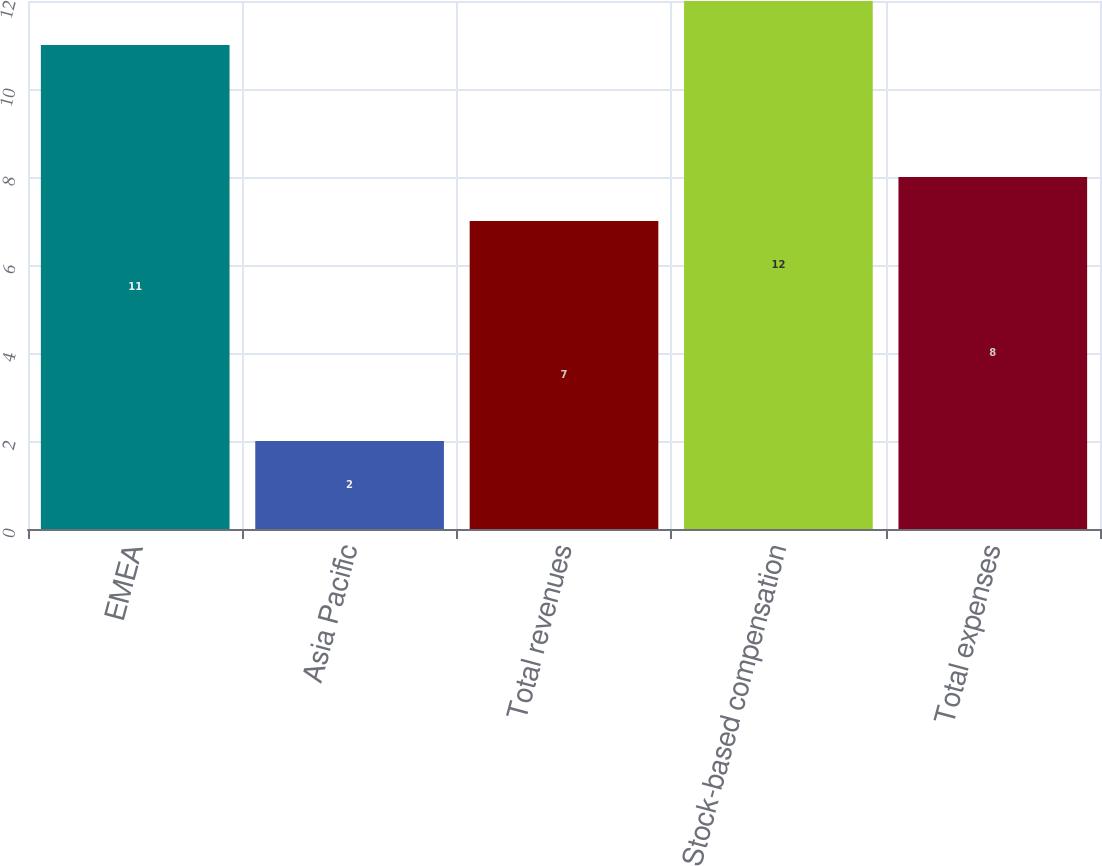Convert chart to OTSL. <chart><loc_0><loc_0><loc_500><loc_500><bar_chart><fcel>EMEA<fcel>Asia Pacific<fcel>Total revenues<fcel>Stock-based compensation<fcel>Total expenses<nl><fcel>11<fcel>2<fcel>7<fcel>12<fcel>8<nl></chart> 